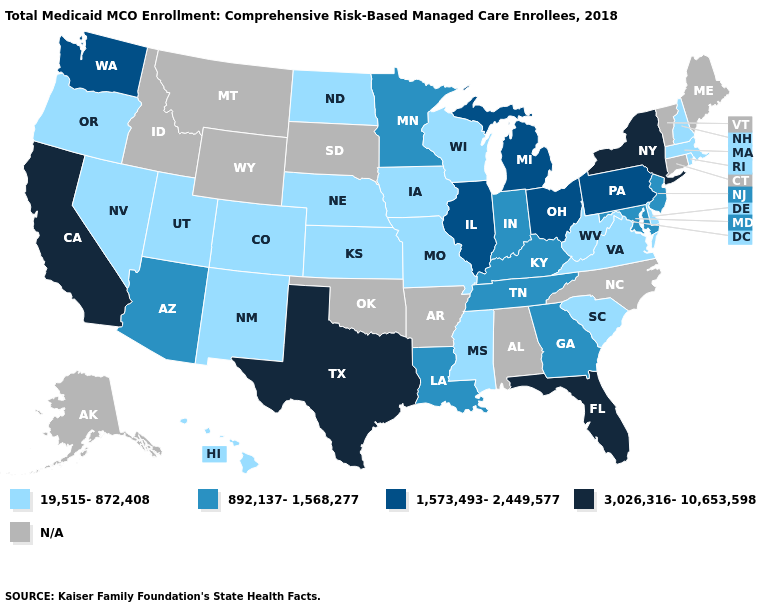Which states have the lowest value in the USA?
Give a very brief answer. Colorado, Delaware, Hawaii, Iowa, Kansas, Massachusetts, Mississippi, Missouri, Nebraska, Nevada, New Hampshire, New Mexico, North Dakota, Oregon, Rhode Island, South Carolina, Utah, Virginia, West Virginia, Wisconsin. Name the states that have a value in the range 892,137-1,568,277?
Quick response, please. Arizona, Georgia, Indiana, Kentucky, Louisiana, Maryland, Minnesota, New Jersey, Tennessee. Which states have the lowest value in the USA?
Short answer required. Colorado, Delaware, Hawaii, Iowa, Kansas, Massachusetts, Mississippi, Missouri, Nebraska, Nevada, New Hampshire, New Mexico, North Dakota, Oregon, Rhode Island, South Carolina, Utah, Virginia, West Virginia, Wisconsin. What is the highest value in the USA?
Keep it brief. 3,026,316-10,653,598. What is the value of Delaware?
Be succinct. 19,515-872,408. Name the states that have a value in the range 19,515-872,408?
Be succinct. Colorado, Delaware, Hawaii, Iowa, Kansas, Massachusetts, Mississippi, Missouri, Nebraska, Nevada, New Hampshire, New Mexico, North Dakota, Oregon, Rhode Island, South Carolina, Utah, Virginia, West Virginia, Wisconsin. Name the states that have a value in the range 1,573,493-2,449,577?
Give a very brief answer. Illinois, Michigan, Ohio, Pennsylvania, Washington. Which states have the lowest value in the USA?
Short answer required. Colorado, Delaware, Hawaii, Iowa, Kansas, Massachusetts, Mississippi, Missouri, Nebraska, Nevada, New Hampshire, New Mexico, North Dakota, Oregon, Rhode Island, South Carolina, Utah, Virginia, West Virginia, Wisconsin. Name the states that have a value in the range 19,515-872,408?
Be succinct. Colorado, Delaware, Hawaii, Iowa, Kansas, Massachusetts, Mississippi, Missouri, Nebraska, Nevada, New Hampshire, New Mexico, North Dakota, Oregon, Rhode Island, South Carolina, Utah, Virginia, West Virginia, Wisconsin. What is the value of New Hampshire?
Concise answer only. 19,515-872,408. Among the states that border Iowa , which have the highest value?
Quick response, please. Illinois. Does West Virginia have the highest value in the South?
Short answer required. No. Name the states that have a value in the range 3,026,316-10,653,598?
Concise answer only. California, Florida, New York, Texas. What is the value of New Jersey?
Be succinct. 892,137-1,568,277. 